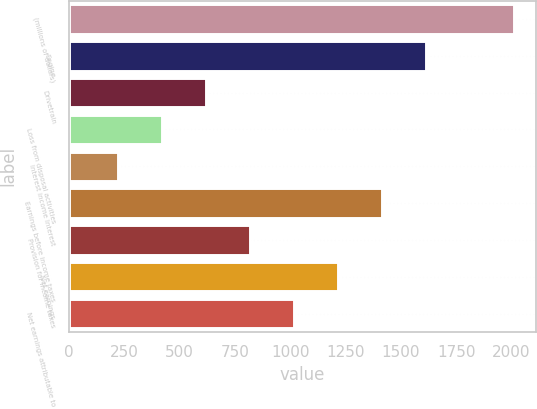<chart> <loc_0><loc_0><loc_500><loc_500><bar_chart><fcel>(millions of dollars)<fcel>Engine<fcel>Drivetrain<fcel>Loss from disposal activities<fcel>Interest income Interest<fcel>Earnings before income taxes<fcel>Provision for income taxes<fcel>Net earnings<fcel>Net earnings attributable to<nl><fcel>2012<fcel>1613.9<fcel>618.65<fcel>419.6<fcel>220.55<fcel>1414.85<fcel>817.7<fcel>1215.8<fcel>1016.75<nl></chart> 